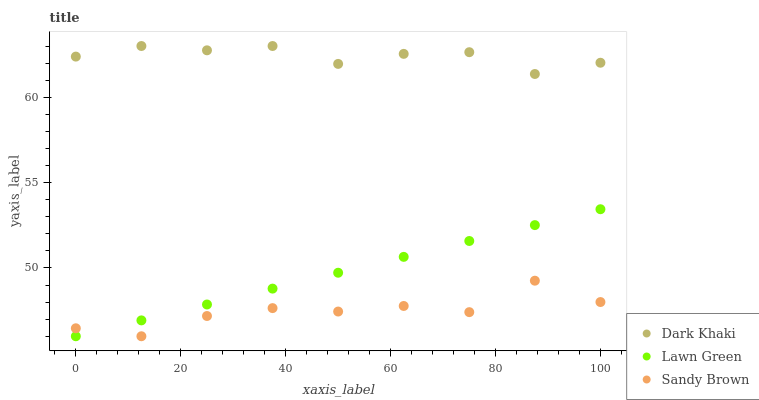Does Sandy Brown have the minimum area under the curve?
Answer yes or no. Yes. Does Dark Khaki have the maximum area under the curve?
Answer yes or no. Yes. Does Lawn Green have the minimum area under the curve?
Answer yes or no. No. Does Lawn Green have the maximum area under the curve?
Answer yes or no. No. Is Lawn Green the smoothest?
Answer yes or no. Yes. Is Sandy Brown the roughest?
Answer yes or no. Yes. Is Sandy Brown the smoothest?
Answer yes or no. No. Is Lawn Green the roughest?
Answer yes or no. No. Does Lawn Green have the lowest value?
Answer yes or no. Yes. Does Dark Khaki have the highest value?
Answer yes or no. Yes. Does Lawn Green have the highest value?
Answer yes or no. No. Is Sandy Brown less than Dark Khaki?
Answer yes or no. Yes. Is Dark Khaki greater than Lawn Green?
Answer yes or no. Yes. Does Sandy Brown intersect Lawn Green?
Answer yes or no. Yes. Is Sandy Brown less than Lawn Green?
Answer yes or no. No. Is Sandy Brown greater than Lawn Green?
Answer yes or no. No. Does Sandy Brown intersect Dark Khaki?
Answer yes or no. No. 